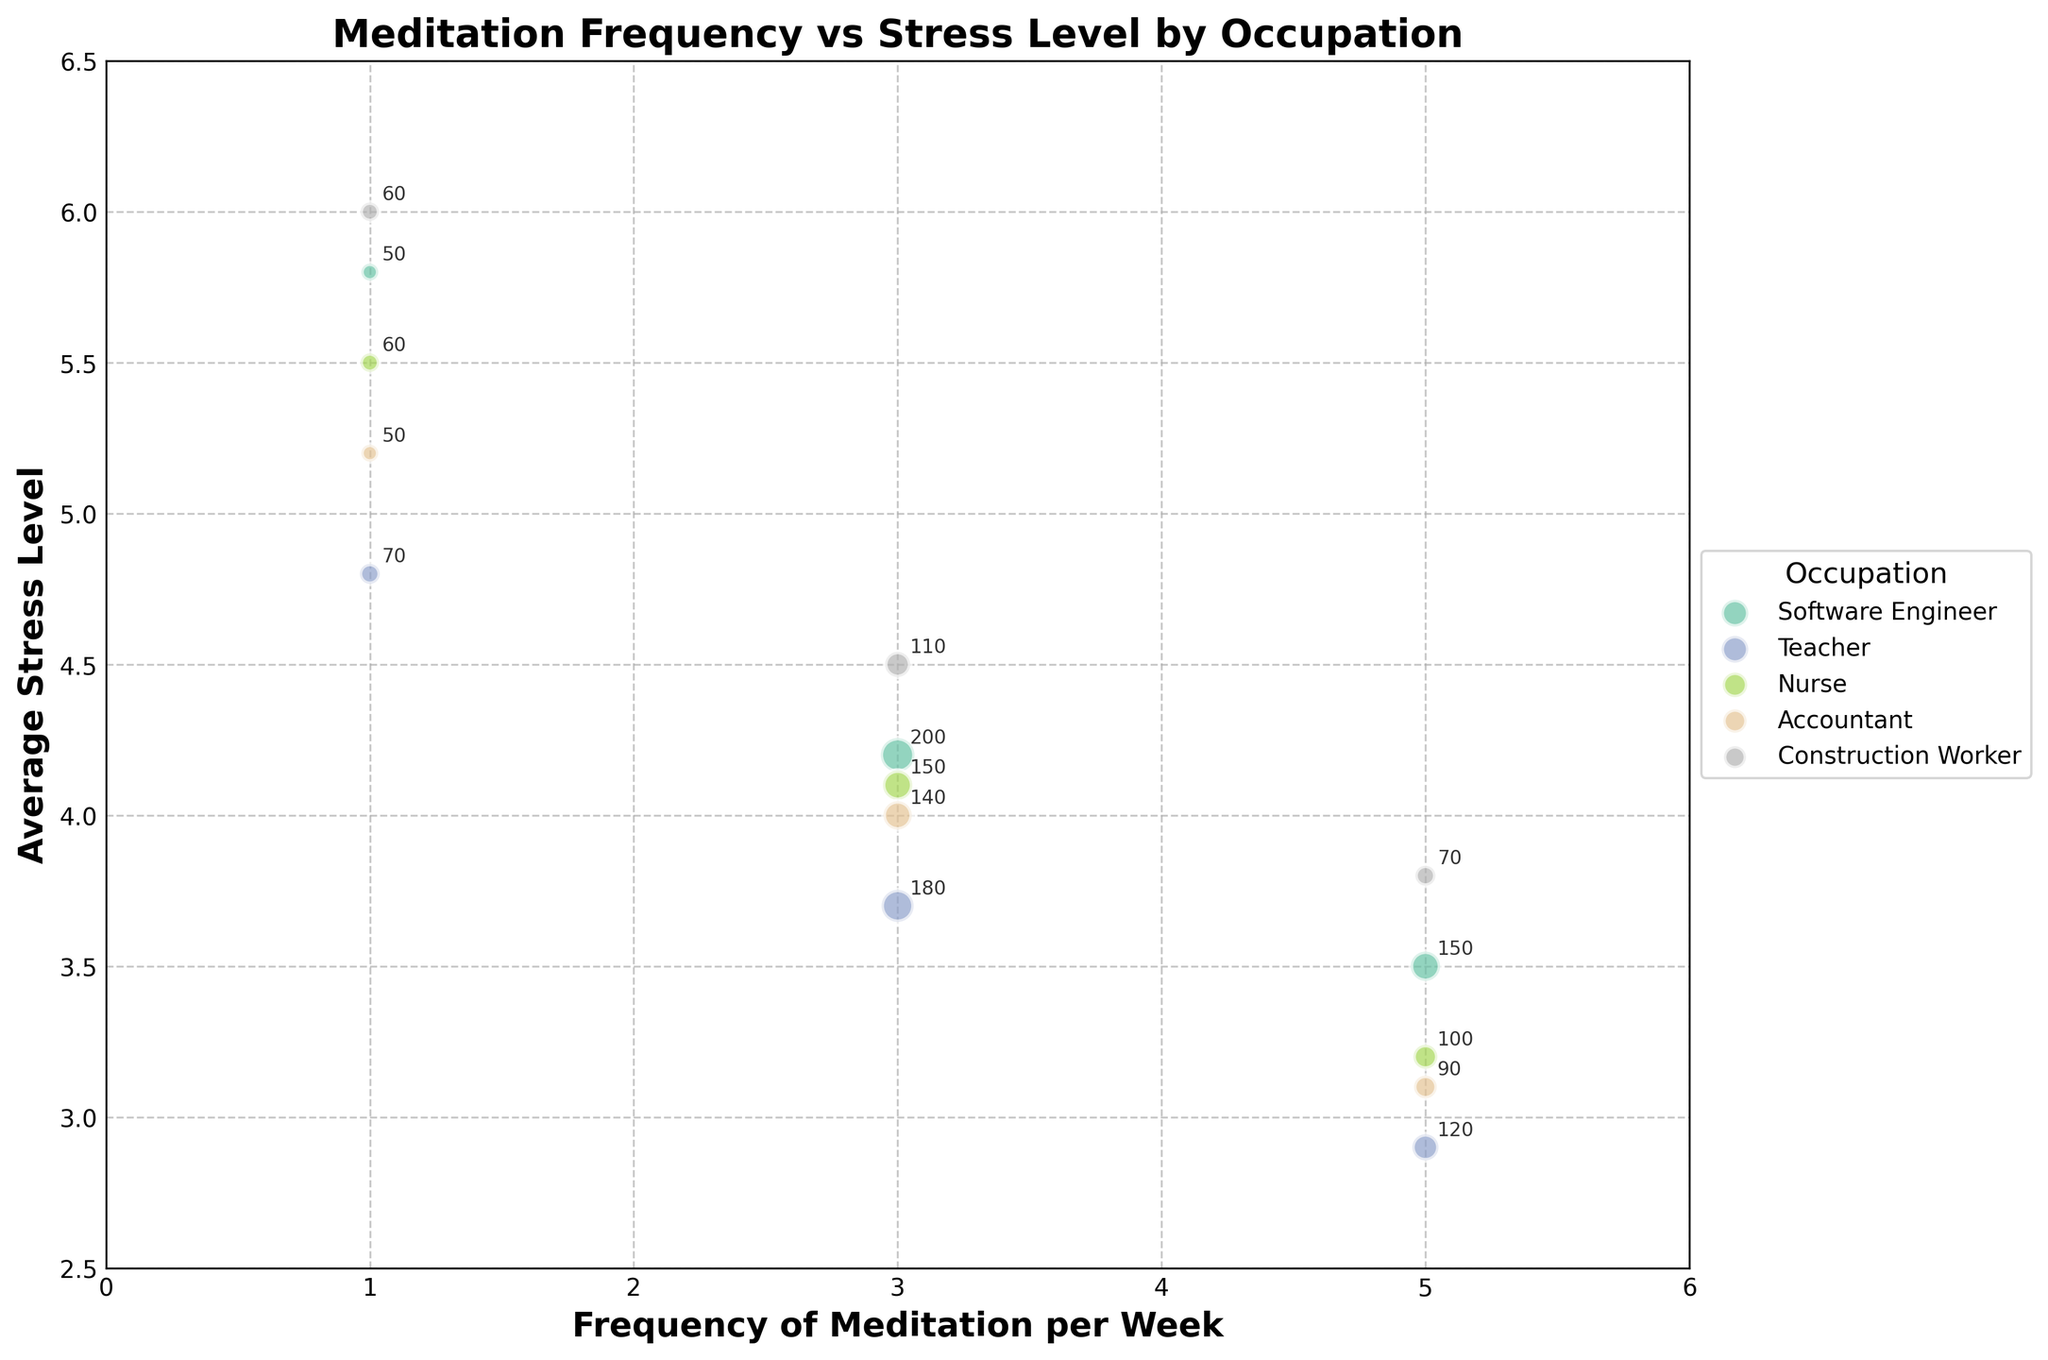What is the title of the plot? The title of the plot is displayed at the top and summarizes the content.
Answer: Meditation Frequency vs Stress Level by Occupation Which occupation has the highest average stress level for people meditating once a week? By looking at the points corresponding to a frequency of 1 and comparing their stress levels, the highest point is identified.
Answer: Construction Worker How many occupations are represented in the plot? The legend lists all unique occupations that are represented in the plot. Counting the legend entries provides the number of occupations.
Answer: 5 What is the average stress level for teachers who meditate 3 times a week? Look at the point representing teachers who meditate 3 times a week and note the average stress level.
Answer: 3.7 Which occupation has the most employees meditating 5 times a week? Identify the largest bubble corresponding to a frequency of 5 and check its associated occupation.
Answer: Software Engineer Which occupation shows the lowest average stress level when meditating 5 times a week? Compare the stress levels of all points corresponding to a frequency of 5 and identify the smallest value and its occupation.
Answer: Teacher What is the difference in average stress level between Software Engineers meditating 3 times a week and Accountants meditating 3 times a week? Subtract the stress level of Accountants from that of Software Engineers for a frequency of 3.
Answer: 0.2 How many employees in total meditate 3 times a week across all occupations? Sum the 'Number of Employees' for all points where the frequency of meditation is 3.
Answer: 780 Which occupation shows a decreasing trend in stress levels as meditation frequency increases? Check the trend of stress levels for each occupation as the frequency increases, identifying any that show a consistent decrease.
Answer: Accountant Which occupation has the smallest variation in average stress levels across different frequencies of meditation? Examine the range of stress levels for each occupation by comparing the highest and lowest levels, and find the smallest range.
Answer: Teacher 